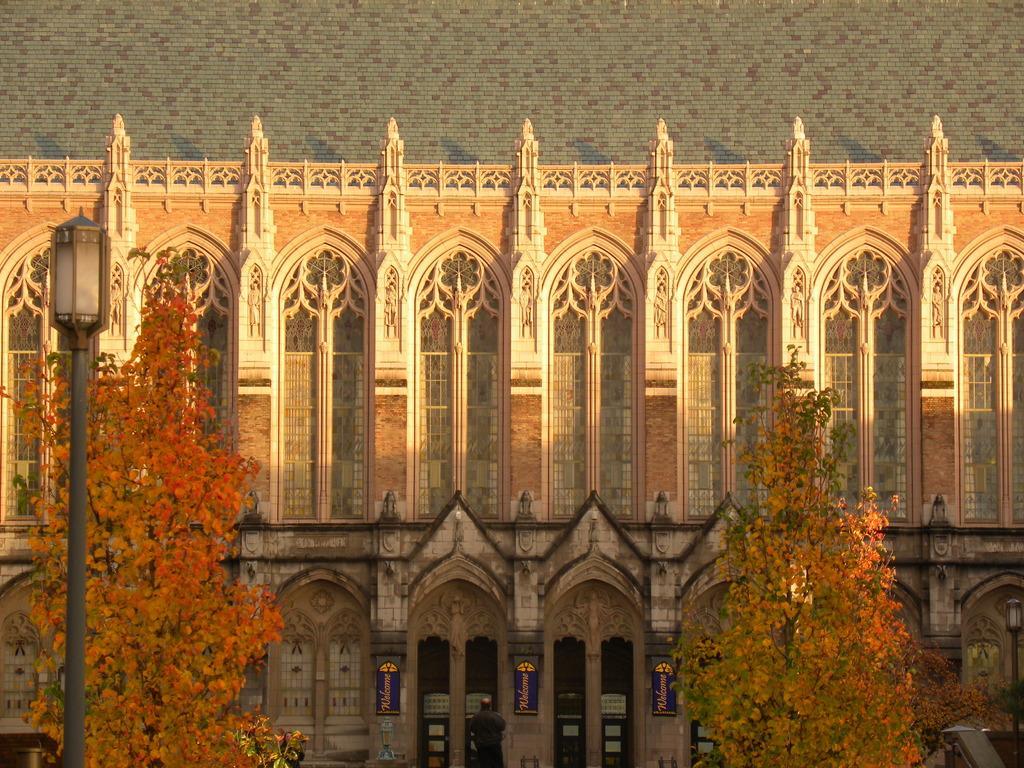Could you give a brief overview of what you see in this image? In the image there is a building in the back with many windows all over it and there are trees in front of it with a street light on the left side. 